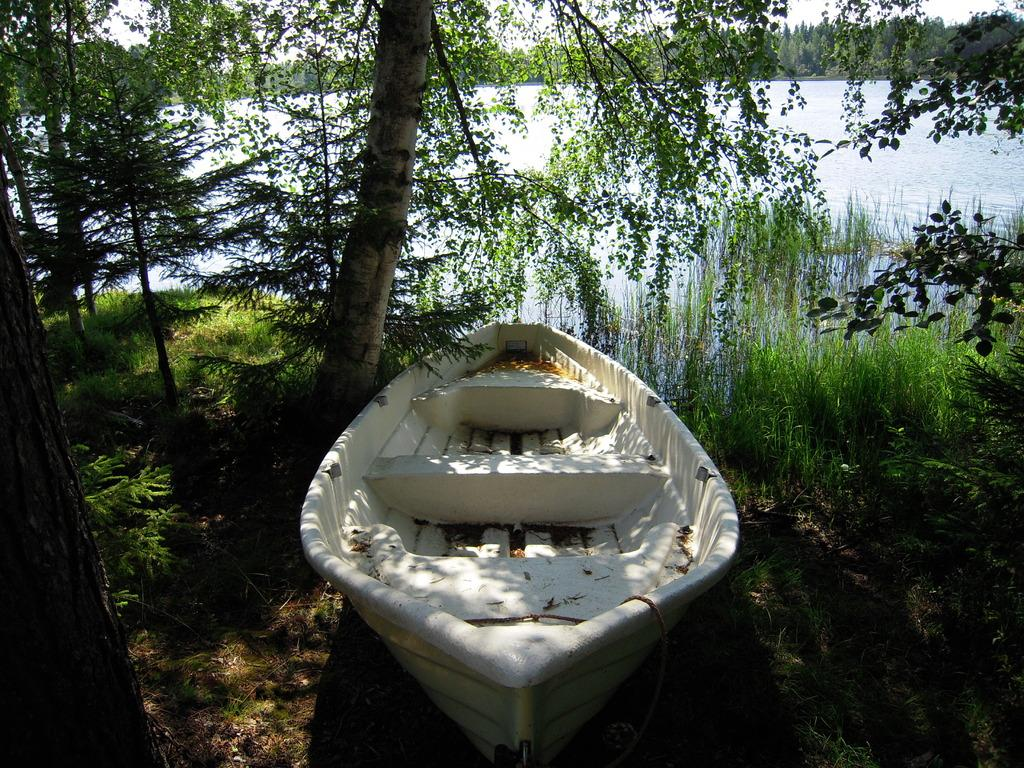What is the main subject of the image? The main subject of the image is a boat. What can be seen in the background of the image? There is water visible in the image, and trees are around the boat. What type of terrain is present in the image? There is grass on the ground in the image. What color is the curtain hanging in the boat? There is no curtain present in the boat or the image. 